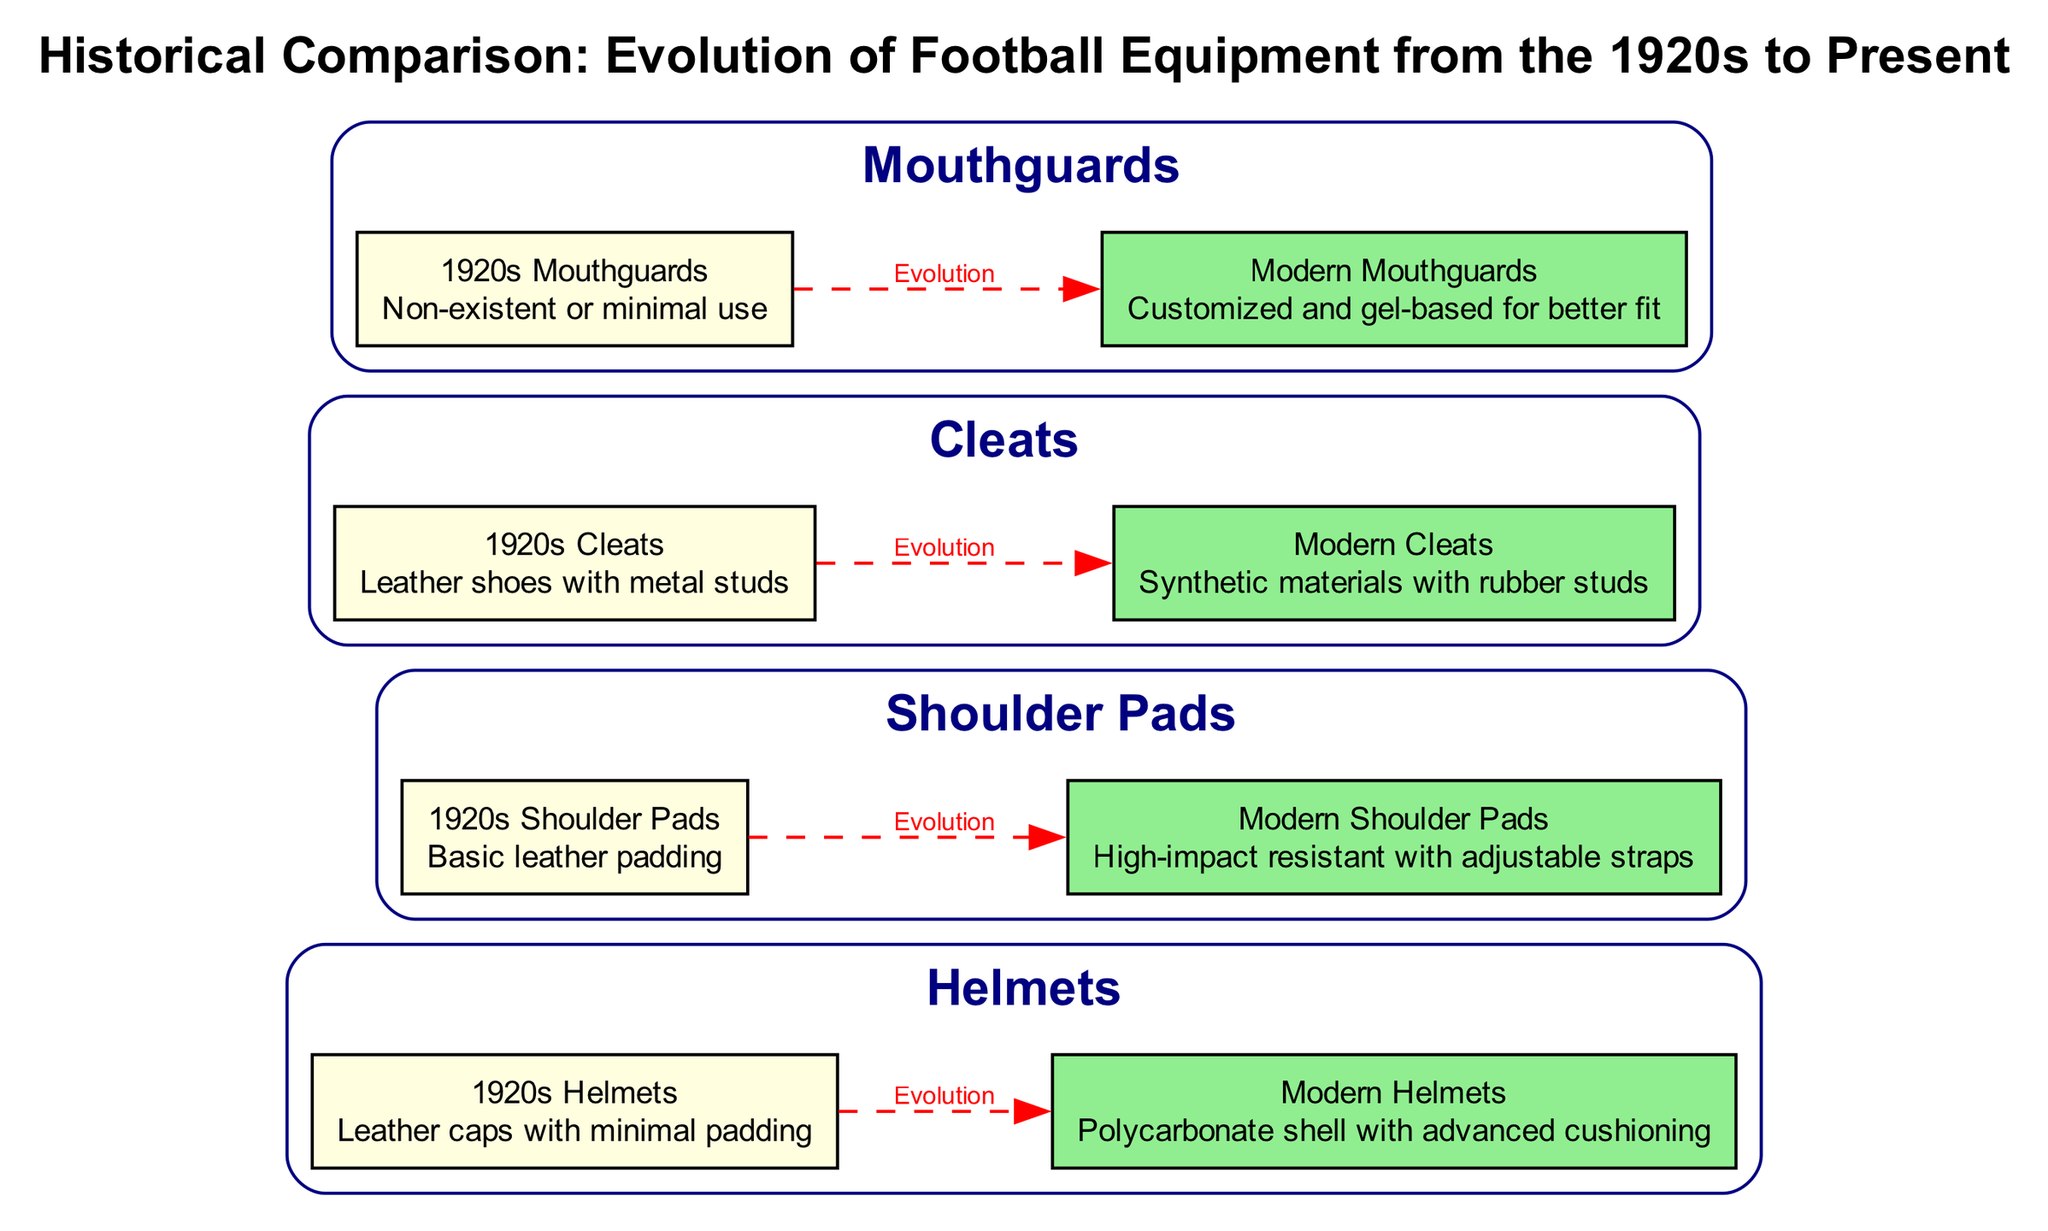What type of padding did 1920s helmets have? The diagram states that 1920s helmets had "Leather caps with minimal padding," specifically mentioned under the 1920s Helmets node.
Answer: Leather caps with minimal padding How many equipment types are represented in the diagram? The diagram includes four equipment types: helmets, shoulder pads, cleats, and mouthguards, which can be counted by looking at the subgraphs for each equipment.
Answer: Four What was the material used for 1920s cleats? According to the 1920s Cleats node in the diagram, the material used was "Leather shoes with metal studs," which is explicitly stated in the details of that node.
Answer: Leather shoes with metal studs What is the main difference between modern and 1920s shoulder pads? The modern shoulder pads are described as "High-impact resistant with adjustable straps," whereas 1920s shoulder pads are simply "Basic leather padding." This shows a significant advancement in material and functionality from one era to the next.
Answer: High-impact resistant with adjustable straps Why might modern mouthguards be considered superior to those from the 1920s? The diagram indicates that modern mouthguards are "Customized and gel-based for better fit," while those from the 1920s were "Non-existent or minimal use." This contrast highlights a major improvement in protection and fit.
Answer: Customized and gel-based for better fit What evolution relationship is shown between modern and 1920s helmets? The diagram clearly illustrates a dashed edge labeled "Evolution" connecting the node for 1920s helmets to modern helmets, indicating a direct progression and improvement over time.
Answer: Evolution Which equipment type shows the most improvement in terms of protective technology? The diagram indicates that both modern helmets and modern shoulder pads use advanced materials and technologies, but the shoulder pads emphasize high-impact resistance specifically, making them notable for their protective enhancement.
Answer: Shoulder pads How are the modern cleats designed compared to the 1920s cleats? The modern cleats are described as "Synthetic materials with rubber studs," indicating a shift from leather with metal studs, which enhances durability and performance. This signifies a modernization in the design and materials used.
Answer: Synthetic materials with rubber studs 